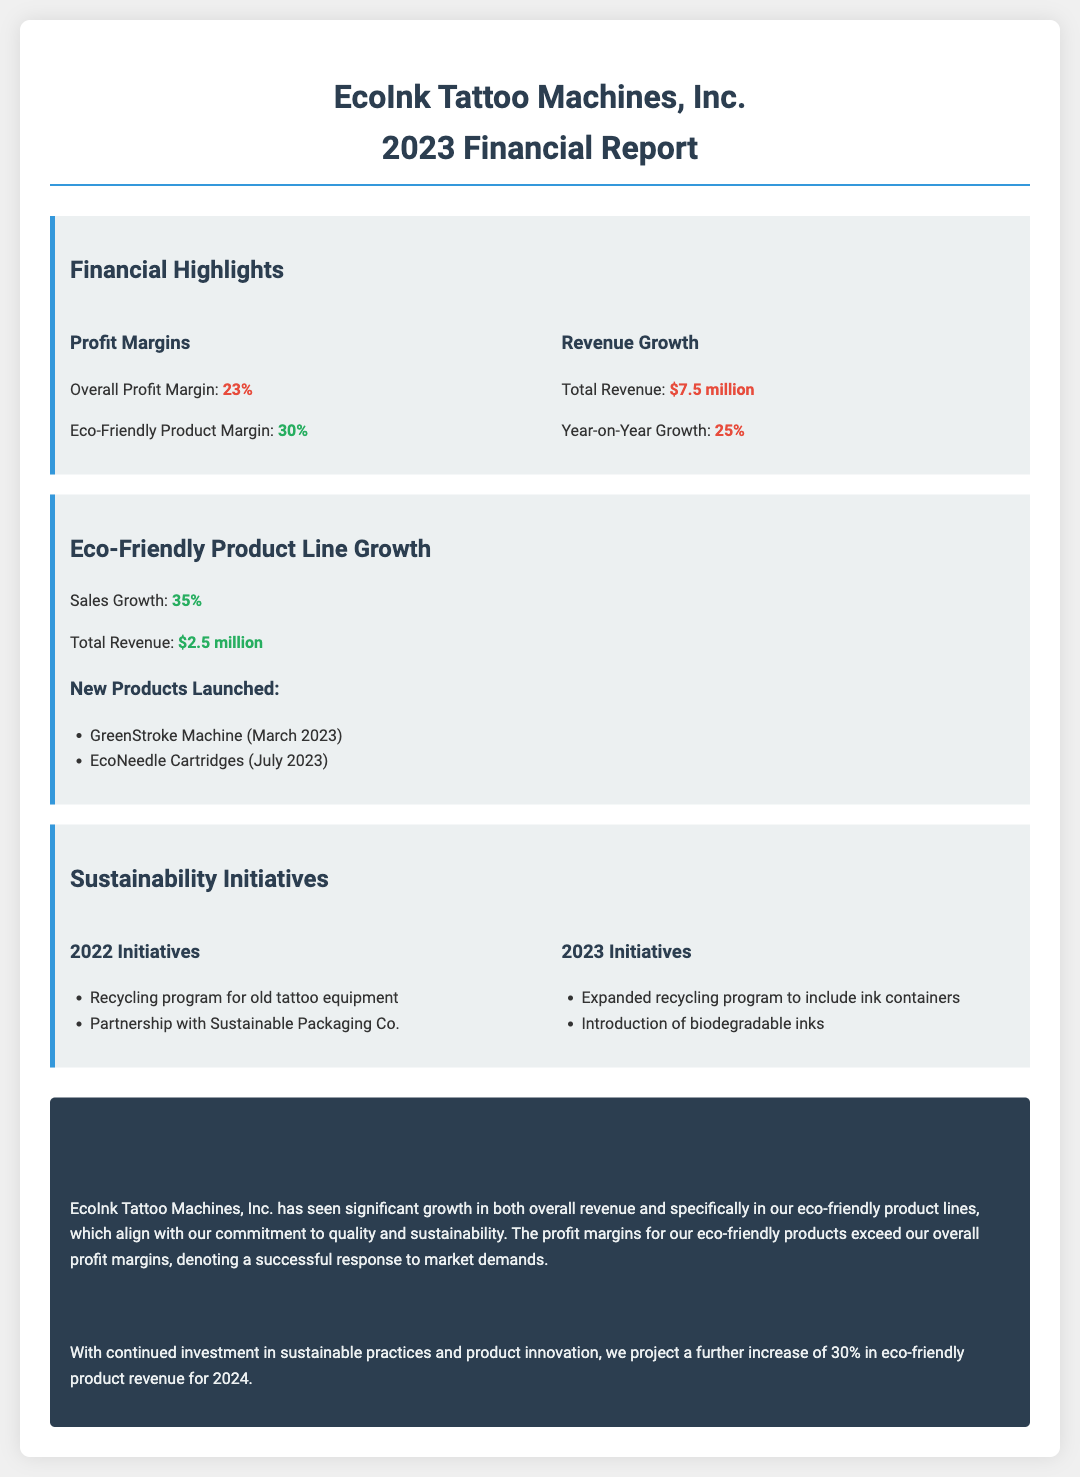What is the overall profit margin? The overall profit margin is specifically stated in the document, which is 23%.
Answer: 23% What is the revenue from eco-friendly products? The document specifies that the total revenue from eco-friendly products is $2.5 million.
Answer: $2.5 million What was the year-on-year growth rate? The document mentions that the year-on-year growth rate is 25%.
Answer: 25% Which new eco-friendly product was launched in March 2023? The document lists the GreenStroke Machine as a new product launched in March 2023.
Answer: GreenStroke Machine What is the profit margin for eco-friendly products? The profit margin for eco-friendly products is specifically mentioned in the document as 30%.
Answer: 30% What is the expected increase in eco-friendly product revenue for 2024? The document states that the projected increase for 2024 is 30%.
Answer: 30% What sustainability initiative was introduced in 2023? The document lists the introduction of biodegradable inks as a 2023 initiative.
Answer: Introduction of biodegradable inks What was the total revenue for EcoInk Tattoo Machines in 2023? The document indicates that the total revenue for 2023 is $7.5 million.
Answer: $7.5 million What partnership was made for sustainability in 2022? The document mentions a partnership with Sustainable Packaging Co. as a 2022 initiative.
Answer: Partnership with Sustainable Packaging Co 